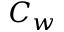<formula> <loc_0><loc_0><loc_500><loc_500>C _ { w }</formula> 